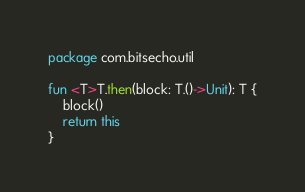Convert code to text. <code><loc_0><loc_0><loc_500><loc_500><_Kotlin_>package com.bitsecho.util

fun <T>T.then(block: T.()->Unit): T {
    block()
    return this
}</code> 